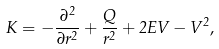<formula> <loc_0><loc_0><loc_500><loc_500>K = - \frac { \partial ^ { 2 } } { \partial r ^ { 2 } } + \frac { Q } { r ^ { 2 } } + 2 E V - V ^ { 2 } ,</formula> 